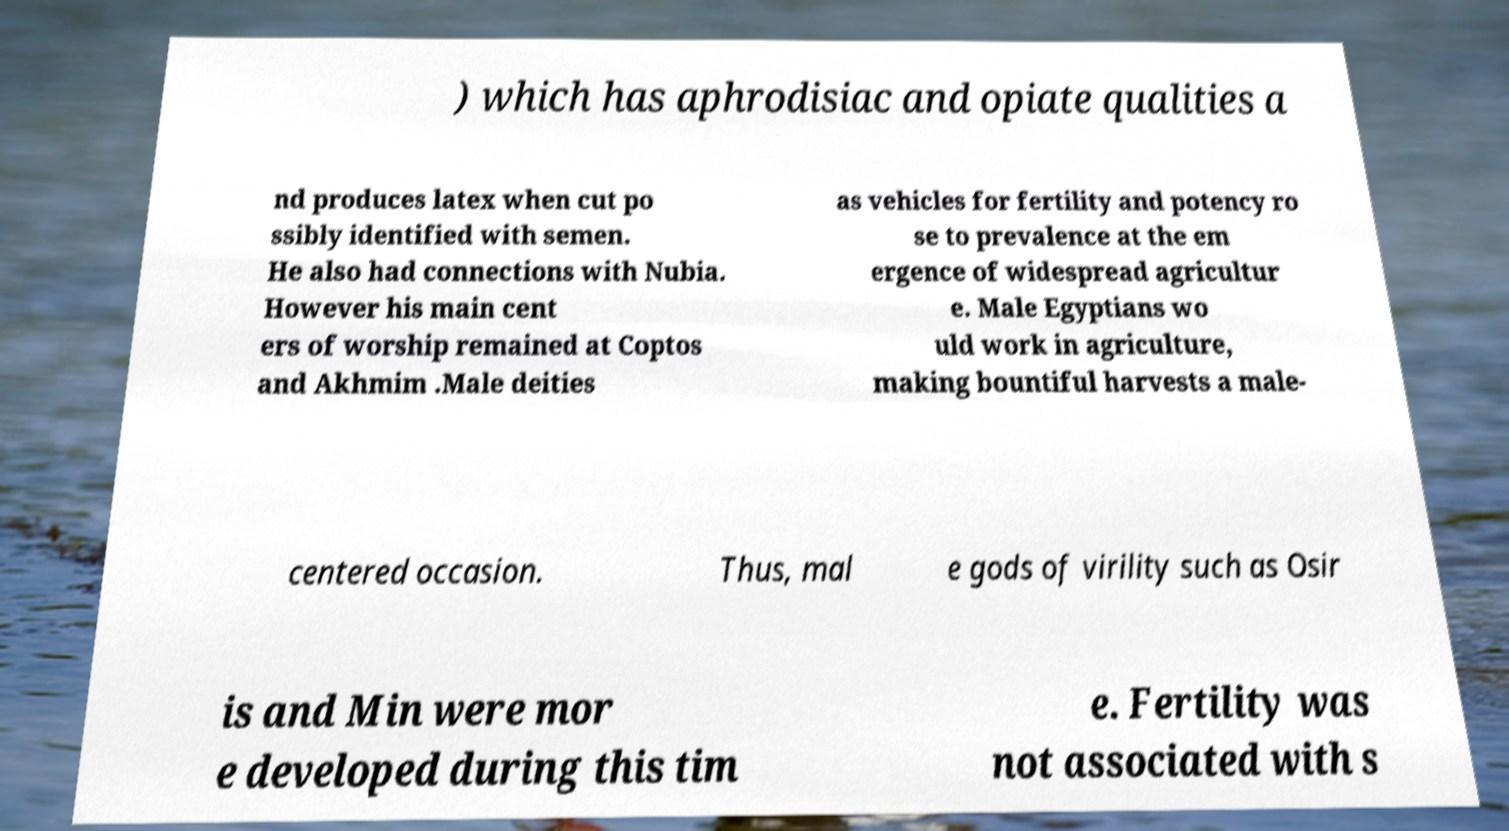Can you accurately transcribe the text from the provided image for me? ) which has aphrodisiac and opiate qualities a nd produces latex when cut po ssibly identified with semen. He also had connections with Nubia. However his main cent ers of worship remained at Coptos and Akhmim .Male deities as vehicles for fertility and potency ro se to prevalence at the em ergence of widespread agricultur e. Male Egyptians wo uld work in agriculture, making bountiful harvests a male- centered occasion. Thus, mal e gods of virility such as Osir is and Min were mor e developed during this tim e. Fertility was not associated with s 